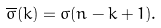<formula> <loc_0><loc_0><loc_500><loc_500>\overline { \sigma } ( k ) = \sigma ( n - k + 1 ) .</formula> 